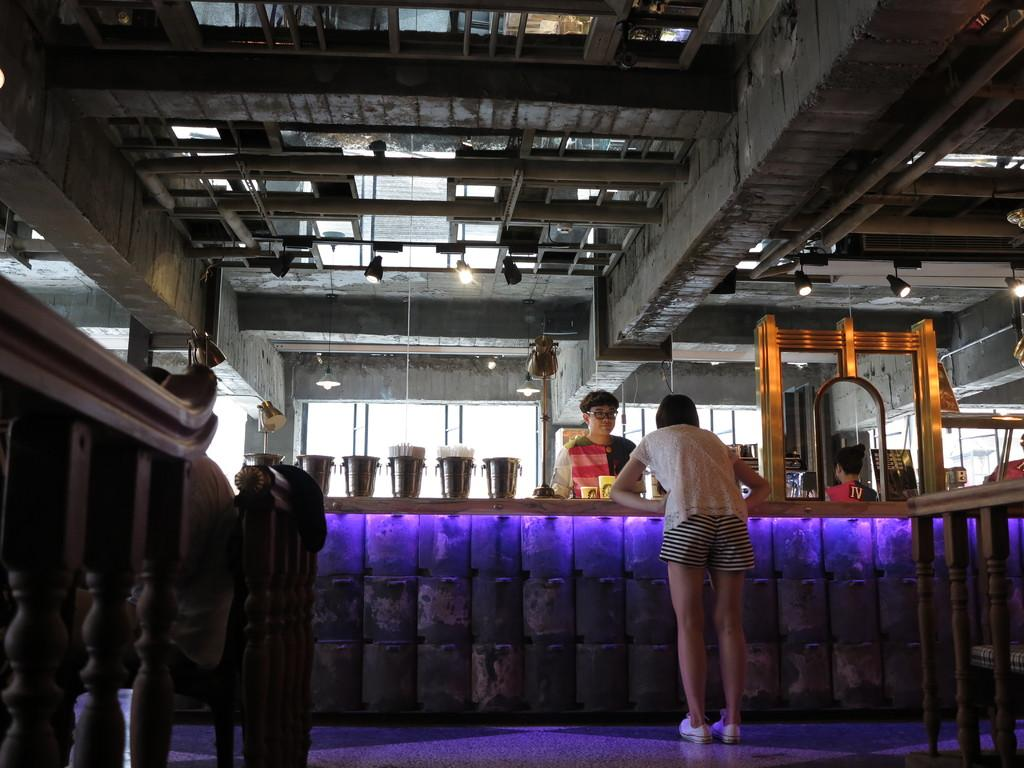What can be seen in the image involving people? There are people standing in the image. What is present in the image that might be used for support or safety? There is a railing in the image. What objects are on a table in the image? There are jars on a table in the image. What is in the image that might frame or enclose something? There is a frame in the image. What can be seen in the image that allows light and air to enter? There are windows in the image. What is present in the image that supports the roof? There is a roof with metal rods in the image. What is in the image that provides artificial light? There are ceiling lights in the image. What type of bone is visible in the image? There is no bone present in the image. 